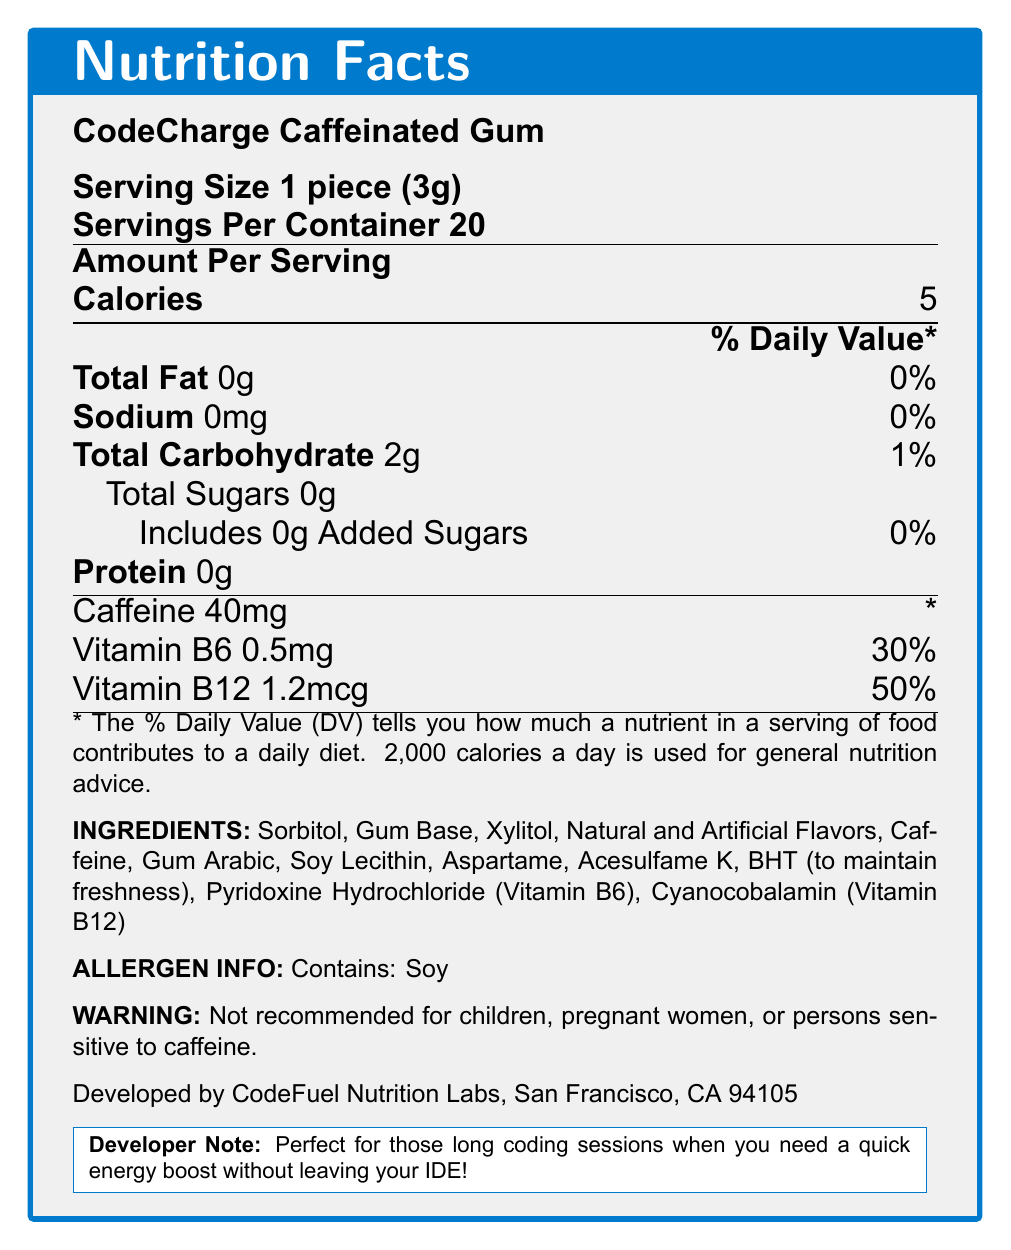what is the serving size of CodeCharge Caffeinated Gum? The serving size is directly mentioned under the product name in the document as "Serving Size 1 piece (3g)".
Answer: 1 piece (3g) how many servings are in a container? The document lists "Servings Per Container 20", which indicates there are 20 servings in a container.
Answer: 20 how many calories are there per serving? Under "Amount Per Serving", the document specifies that each serving contains 5 calories.
Answer: 5 what is the total carbohydrate content per serving? The document states the "Total Carbohydrate" content as 2g next to the % Daily Value information.
Answer: 2g how much caffeine is in one piece of gum? The caffeine content per piece is listed as 40mg in the section dedicated to nutritional information.
Answer: 40mg what vitamins are found in CodeCharge Caffeinated Gum? The document lists "Vitamin B6 0.5mg" and "Vitamin B12 1.2mcg" under the nutritional information.
Answer: Vitamin B6 and Vitamin B12 how much vitamin B12 is in one serving? According to the document, one serving contains 1.2mcg of Vitamin B12.
Answer: 1.2mcg how many grams of protein are in each serving? The document specifies that the protein content per serving is 0g.
Answer: 0g what is the % Daily Value of Vitamin B6 in each piece? The % Daily Value of Vitamin B6 per serving is explicitly noted as 30%.
Answer: 30% are there any added sugars in the gum? The document lists "Includes 0g Added Sugars" under the "Total Sugars" section.
Answer: No which ingredient is used to maintain freshness? A. Aspartame B. BHT C. Soy Lecithin D. Sorbitol The document states "BHT (to maintain freshness)" in the ingredients section, indicating BHT is used for this purpose.
Answer: B. BHT what ingredient might be problematic for those with allergies? A. Xylitol B. Aspartame C. Gum Arabic D. Soy Lecithin The allergen information mentions "Contains: Soy", so Soy Lecithin may be problematic for those with allergies.
Answer: D. Soy Lecithin is it safe for children to consume CodeCharge Caffeinated Gum? The document includes a warning stating that it is "Not recommended for children, pregnant women, or persons sensitive to caffeine."
Answer: No who manufactures CodeCharge Caffeinated Gum? The manufacturer information at the bottom of the document states that it is developed by CodeFuel Nutrition Labs in San Francisco, CA 94105.
Answer: CodeFuel Nutrition Labs, San Francisco, CA 94105 summarize the main idea of the document. The document mainly serves to provide comprehensive nutritional details about CodeCharge Caffeinated Gum, including serving size, calorie count, key vitamins, ingredients list, allergen information, and warnings about caffeine content. It highlights the product's suitability for coders needing a quick energy lift.
Answer: CodeCharge Caffeinated Gum is a nutrition product designed for quick energy boosts, providing detailed nutritional information such as serving size, calorie content, ingredients, and warnings. It's particularly formulated for coders and contains caffeine, Vitamin B6, and Vitamin B12. can you tell how this document was created based on the visual information? The document provides detailed nutritional and ingredient information about the gum but does not provide any details on how the document was created or generated.
Answer: Not enough information 